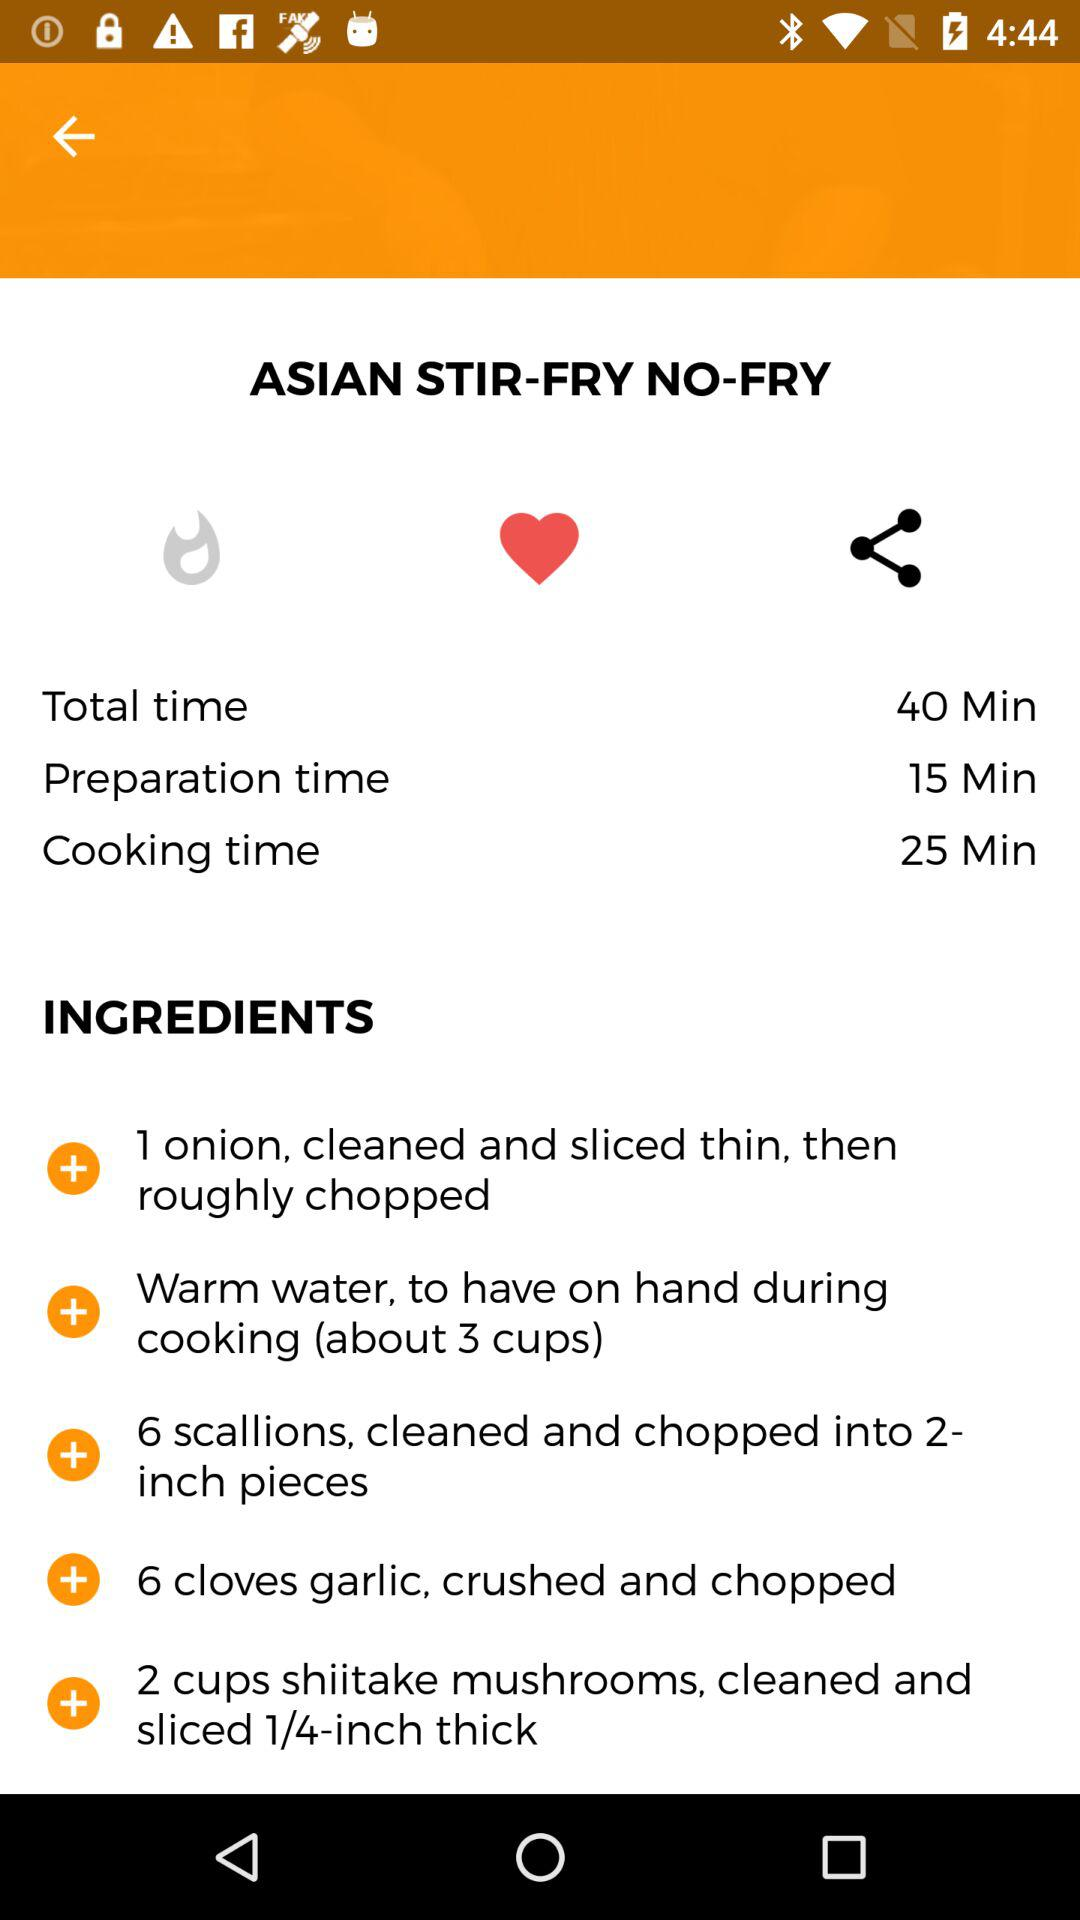What is the duration of 25 minutes given for? The duration of 25 minutes is given for cooking time. 